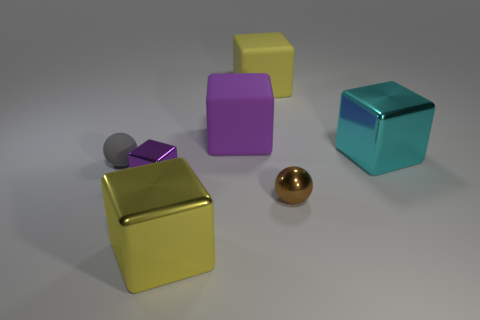Subtract all large cyan cubes. How many cubes are left? 4 Subtract all cyan cubes. How many cubes are left? 4 Subtract all gray blocks. Subtract all gray balls. How many blocks are left? 5 Add 2 tiny gray balls. How many objects exist? 9 Subtract all blocks. How many objects are left? 2 Subtract 1 purple blocks. How many objects are left? 6 Subtract all small purple metallic blocks. Subtract all small metal cubes. How many objects are left? 5 Add 6 large yellow objects. How many large yellow objects are left? 8 Add 2 metal objects. How many metal objects exist? 6 